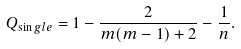Convert formula to latex. <formula><loc_0><loc_0><loc_500><loc_500>Q _ { \sin g l e } = 1 - \frac { 2 } { m ( m - 1 ) + 2 } - \frac { 1 } { n } .</formula> 